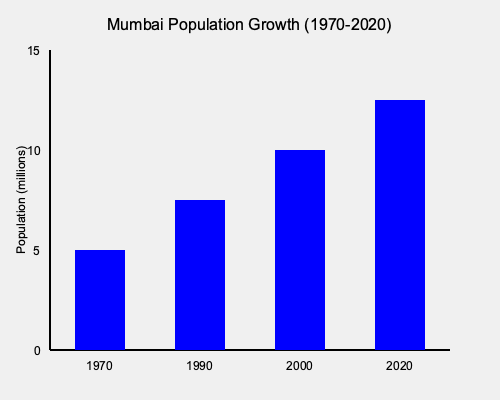Based on the bar graph showing Mumbai's population growth from 1970 to 2020, what political and urban planning challenges might the city have faced due to this rapid increase, and how could these challenges impact local governance and infrastructure development? To answer this question, let's analyze the graph and consider the implications of Mumbai's population growth:

1. Population Trend:
   - 1970: Approximately 5 million
   - 1990: Around 7.5 million
   - 2000: About 10 million
   - 2020: Approximately 12.5 million

2. Rate of Growth:
   - 1970-1990: 50% increase in 20 years
   - 1990-2000: 33% increase in 10 years
   - 2000-2020: 25% increase in 20 years

3. Political Challenges:
   a) Voter demographics: Rapid influx of migrants could change voting patterns
   b) Representation: Need for redistricting and possibly creating new constituencies
   c) Policy priorities: Shift towards urban-centric issues

4. Urban Planning Challenges:
   a) Housing: Increased demand leading to informal settlements and slums
   b) Transportation: Strain on existing public transport systems
   c) Water and sanitation: Need for expanded infrastructure
   d) Healthcare and education: Requirement for more facilities

5. Governance Impacts:
   a) Resource allocation: Balancing between different sectors and areas
   b) Urban-rural divide: Focus on urban issues might neglect rural areas
   c) Environmental concerns: Balancing development with sustainability

6. Infrastructure Development:
   a) Pressure to rapidly develop infrastructure to keep pace with population growth
   b) Need for long-term planning to accommodate future growth
   c) Potential for public-private partnerships to meet infrastructure demands

The rapid population growth would necessitate a shift in political focus towards urban development, potentially straining resources and requiring innovative governance solutions to address the multifaceted challenges of a rapidly expanding metropolis.
Answer: Rapid urbanization led to challenges in housing, transportation, and basic services, requiring innovative governance and infrastructure solutions to balance development with sustainability. 